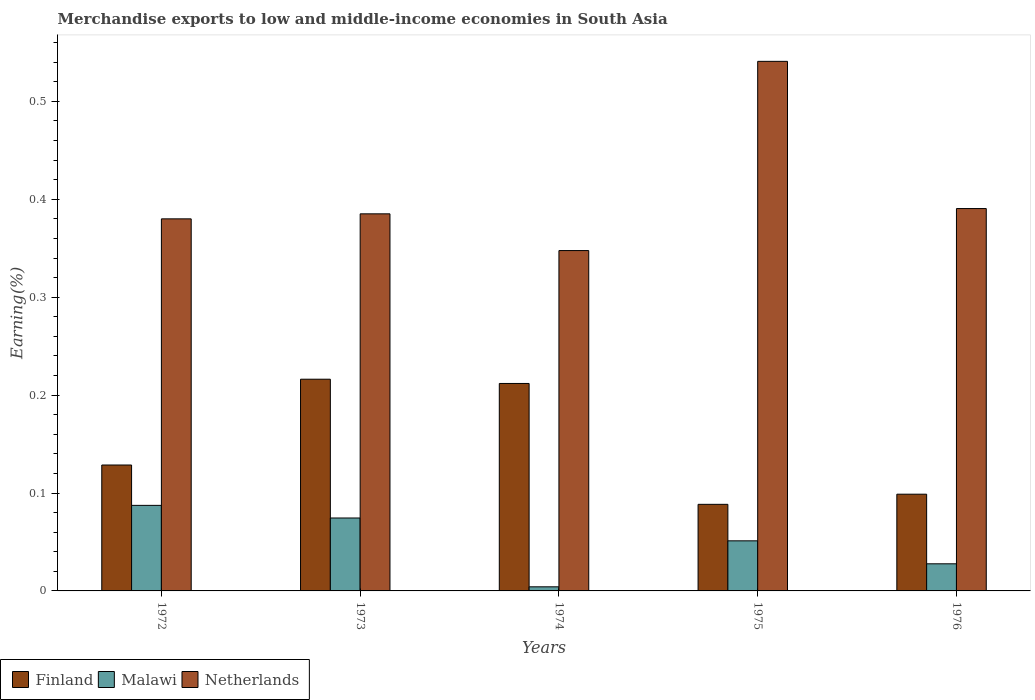How many different coloured bars are there?
Offer a very short reply. 3. How many groups of bars are there?
Offer a terse response. 5. Are the number of bars per tick equal to the number of legend labels?
Your answer should be compact. Yes. How many bars are there on the 5th tick from the left?
Provide a short and direct response. 3. How many bars are there on the 4th tick from the right?
Ensure brevity in your answer.  3. What is the label of the 5th group of bars from the left?
Your answer should be compact. 1976. What is the percentage of amount earned from merchandise exports in Malawi in 1976?
Make the answer very short. 0.03. Across all years, what is the maximum percentage of amount earned from merchandise exports in Malawi?
Provide a succinct answer. 0.09. Across all years, what is the minimum percentage of amount earned from merchandise exports in Malawi?
Offer a terse response. 0. In which year was the percentage of amount earned from merchandise exports in Netherlands maximum?
Give a very brief answer. 1975. In which year was the percentage of amount earned from merchandise exports in Finland minimum?
Give a very brief answer. 1975. What is the total percentage of amount earned from merchandise exports in Netherlands in the graph?
Keep it short and to the point. 2.04. What is the difference between the percentage of amount earned from merchandise exports in Netherlands in 1973 and that in 1975?
Your response must be concise. -0.16. What is the difference between the percentage of amount earned from merchandise exports in Netherlands in 1973 and the percentage of amount earned from merchandise exports in Finland in 1976?
Offer a terse response. 0.29. What is the average percentage of amount earned from merchandise exports in Malawi per year?
Provide a succinct answer. 0.05. In the year 1976, what is the difference between the percentage of amount earned from merchandise exports in Finland and percentage of amount earned from merchandise exports in Netherlands?
Provide a succinct answer. -0.29. What is the ratio of the percentage of amount earned from merchandise exports in Finland in 1972 to that in 1974?
Ensure brevity in your answer.  0.61. Is the percentage of amount earned from merchandise exports in Malawi in 1974 less than that in 1975?
Offer a terse response. Yes. Is the difference between the percentage of amount earned from merchandise exports in Finland in 1973 and 1976 greater than the difference between the percentage of amount earned from merchandise exports in Netherlands in 1973 and 1976?
Ensure brevity in your answer.  Yes. What is the difference between the highest and the second highest percentage of amount earned from merchandise exports in Finland?
Provide a succinct answer. 0. What is the difference between the highest and the lowest percentage of amount earned from merchandise exports in Netherlands?
Offer a terse response. 0.19. In how many years, is the percentage of amount earned from merchandise exports in Netherlands greater than the average percentage of amount earned from merchandise exports in Netherlands taken over all years?
Give a very brief answer. 1. What does the 2nd bar from the left in 1976 represents?
Your answer should be compact. Malawi. What does the 2nd bar from the right in 1974 represents?
Your answer should be compact. Malawi. Is it the case that in every year, the sum of the percentage of amount earned from merchandise exports in Finland and percentage of amount earned from merchandise exports in Netherlands is greater than the percentage of amount earned from merchandise exports in Malawi?
Your response must be concise. Yes. Are all the bars in the graph horizontal?
Your answer should be very brief. No. How many years are there in the graph?
Keep it short and to the point. 5. Are the values on the major ticks of Y-axis written in scientific E-notation?
Your answer should be compact. No. Does the graph contain any zero values?
Offer a terse response. No. How many legend labels are there?
Make the answer very short. 3. What is the title of the graph?
Ensure brevity in your answer.  Merchandise exports to low and middle-income economies in South Asia. What is the label or title of the Y-axis?
Your response must be concise. Earning(%). What is the Earning(%) of Finland in 1972?
Your response must be concise. 0.13. What is the Earning(%) in Malawi in 1972?
Keep it short and to the point. 0.09. What is the Earning(%) in Netherlands in 1972?
Give a very brief answer. 0.38. What is the Earning(%) in Finland in 1973?
Ensure brevity in your answer.  0.22. What is the Earning(%) of Malawi in 1973?
Your answer should be very brief. 0.07. What is the Earning(%) of Netherlands in 1973?
Give a very brief answer. 0.39. What is the Earning(%) of Finland in 1974?
Provide a succinct answer. 0.21. What is the Earning(%) in Malawi in 1974?
Your response must be concise. 0. What is the Earning(%) in Netherlands in 1974?
Your answer should be very brief. 0.35. What is the Earning(%) in Finland in 1975?
Provide a succinct answer. 0.09. What is the Earning(%) of Malawi in 1975?
Ensure brevity in your answer.  0.05. What is the Earning(%) of Netherlands in 1975?
Your response must be concise. 0.54. What is the Earning(%) of Finland in 1976?
Give a very brief answer. 0.1. What is the Earning(%) in Malawi in 1976?
Your answer should be compact. 0.03. What is the Earning(%) in Netherlands in 1976?
Your response must be concise. 0.39. Across all years, what is the maximum Earning(%) in Finland?
Ensure brevity in your answer.  0.22. Across all years, what is the maximum Earning(%) of Malawi?
Your answer should be very brief. 0.09. Across all years, what is the maximum Earning(%) in Netherlands?
Give a very brief answer. 0.54. Across all years, what is the minimum Earning(%) of Finland?
Give a very brief answer. 0.09. Across all years, what is the minimum Earning(%) in Malawi?
Your answer should be compact. 0. Across all years, what is the minimum Earning(%) of Netherlands?
Offer a terse response. 0.35. What is the total Earning(%) in Finland in the graph?
Ensure brevity in your answer.  0.74. What is the total Earning(%) in Malawi in the graph?
Your response must be concise. 0.24. What is the total Earning(%) in Netherlands in the graph?
Your answer should be compact. 2.04. What is the difference between the Earning(%) in Finland in 1972 and that in 1973?
Your answer should be very brief. -0.09. What is the difference between the Earning(%) in Malawi in 1972 and that in 1973?
Offer a very short reply. 0.01. What is the difference between the Earning(%) in Netherlands in 1972 and that in 1973?
Give a very brief answer. -0.01. What is the difference between the Earning(%) in Finland in 1972 and that in 1974?
Give a very brief answer. -0.08. What is the difference between the Earning(%) in Malawi in 1972 and that in 1974?
Offer a very short reply. 0.08. What is the difference between the Earning(%) in Netherlands in 1972 and that in 1974?
Provide a short and direct response. 0.03. What is the difference between the Earning(%) in Finland in 1972 and that in 1975?
Your response must be concise. 0.04. What is the difference between the Earning(%) in Malawi in 1972 and that in 1975?
Your answer should be very brief. 0.04. What is the difference between the Earning(%) in Netherlands in 1972 and that in 1975?
Provide a succinct answer. -0.16. What is the difference between the Earning(%) in Finland in 1972 and that in 1976?
Your answer should be very brief. 0.03. What is the difference between the Earning(%) in Malawi in 1972 and that in 1976?
Provide a short and direct response. 0.06. What is the difference between the Earning(%) of Netherlands in 1972 and that in 1976?
Ensure brevity in your answer.  -0.01. What is the difference between the Earning(%) of Finland in 1973 and that in 1974?
Offer a very short reply. 0. What is the difference between the Earning(%) of Malawi in 1973 and that in 1974?
Your answer should be very brief. 0.07. What is the difference between the Earning(%) in Netherlands in 1973 and that in 1974?
Offer a very short reply. 0.04. What is the difference between the Earning(%) in Finland in 1973 and that in 1975?
Make the answer very short. 0.13. What is the difference between the Earning(%) in Malawi in 1973 and that in 1975?
Ensure brevity in your answer.  0.02. What is the difference between the Earning(%) in Netherlands in 1973 and that in 1975?
Make the answer very short. -0.16. What is the difference between the Earning(%) in Finland in 1973 and that in 1976?
Ensure brevity in your answer.  0.12. What is the difference between the Earning(%) of Malawi in 1973 and that in 1976?
Ensure brevity in your answer.  0.05. What is the difference between the Earning(%) in Netherlands in 1973 and that in 1976?
Your response must be concise. -0.01. What is the difference between the Earning(%) in Finland in 1974 and that in 1975?
Your response must be concise. 0.12. What is the difference between the Earning(%) of Malawi in 1974 and that in 1975?
Provide a succinct answer. -0.05. What is the difference between the Earning(%) of Netherlands in 1974 and that in 1975?
Your answer should be very brief. -0.19. What is the difference between the Earning(%) in Finland in 1974 and that in 1976?
Your answer should be very brief. 0.11. What is the difference between the Earning(%) of Malawi in 1974 and that in 1976?
Keep it short and to the point. -0.02. What is the difference between the Earning(%) in Netherlands in 1974 and that in 1976?
Ensure brevity in your answer.  -0.04. What is the difference between the Earning(%) in Finland in 1975 and that in 1976?
Offer a very short reply. -0.01. What is the difference between the Earning(%) in Malawi in 1975 and that in 1976?
Provide a succinct answer. 0.02. What is the difference between the Earning(%) of Netherlands in 1975 and that in 1976?
Provide a short and direct response. 0.15. What is the difference between the Earning(%) of Finland in 1972 and the Earning(%) of Malawi in 1973?
Make the answer very short. 0.05. What is the difference between the Earning(%) of Finland in 1972 and the Earning(%) of Netherlands in 1973?
Provide a succinct answer. -0.26. What is the difference between the Earning(%) in Malawi in 1972 and the Earning(%) in Netherlands in 1973?
Keep it short and to the point. -0.3. What is the difference between the Earning(%) of Finland in 1972 and the Earning(%) of Malawi in 1974?
Your answer should be very brief. 0.12. What is the difference between the Earning(%) in Finland in 1972 and the Earning(%) in Netherlands in 1974?
Your answer should be very brief. -0.22. What is the difference between the Earning(%) of Malawi in 1972 and the Earning(%) of Netherlands in 1974?
Provide a short and direct response. -0.26. What is the difference between the Earning(%) in Finland in 1972 and the Earning(%) in Malawi in 1975?
Ensure brevity in your answer.  0.08. What is the difference between the Earning(%) in Finland in 1972 and the Earning(%) in Netherlands in 1975?
Offer a terse response. -0.41. What is the difference between the Earning(%) in Malawi in 1972 and the Earning(%) in Netherlands in 1975?
Ensure brevity in your answer.  -0.45. What is the difference between the Earning(%) of Finland in 1972 and the Earning(%) of Malawi in 1976?
Your answer should be very brief. 0.1. What is the difference between the Earning(%) in Finland in 1972 and the Earning(%) in Netherlands in 1976?
Your response must be concise. -0.26. What is the difference between the Earning(%) in Malawi in 1972 and the Earning(%) in Netherlands in 1976?
Make the answer very short. -0.3. What is the difference between the Earning(%) in Finland in 1973 and the Earning(%) in Malawi in 1974?
Make the answer very short. 0.21. What is the difference between the Earning(%) in Finland in 1973 and the Earning(%) in Netherlands in 1974?
Keep it short and to the point. -0.13. What is the difference between the Earning(%) in Malawi in 1973 and the Earning(%) in Netherlands in 1974?
Offer a terse response. -0.27. What is the difference between the Earning(%) of Finland in 1973 and the Earning(%) of Malawi in 1975?
Offer a terse response. 0.17. What is the difference between the Earning(%) of Finland in 1973 and the Earning(%) of Netherlands in 1975?
Make the answer very short. -0.32. What is the difference between the Earning(%) of Malawi in 1973 and the Earning(%) of Netherlands in 1975?
Offer a very short reply. -0.47. What is the difference between the Earning(%) in Finland in 1973 and the Earning(%) in Malawi in 1976?
Your answer should be compact. 0.19. What is the difference between the Earning(%) of Finland in 1973 and the Earning(%) of Netherlands in 1976?
Offer a very short reply. -0.17. What is the difference between the Earning(%) of Malawi in 1973 and the Earning(%) of Netherlands in 1976?
Offer a very short reply. -0.32. What is the difference between the Earning(%) in Finland in 1974 and the Earning(%) in Malawi in 1975?
Your answer should be compact. 0.16. What is the difference between the Earning(%) of Finland in 1974 and the Earning(%) of Netherlands in 1975?
Make the answer very short. -0.33. What is the difference between the Earning(%) in Malawi in 1974 and the Earning(%) in Netherlands in 1975?
Offer a terse response. -0.54. What is the difference between the Earning(%) of Finland in 1974 and the Earning(%) of Malawi in 1976?
Give a very brief answer. 0.18. What is the difference between the Earning(%) in Finland in 1974 and the Earning(%) in Netherlands in 1976?
Keep it short and to the point. -0.18. What is the difference between the Earning(%) of Malawi in 1974 and the Earning(%) of Netherlands in 1976?
Keep it short and to the point. -0.39. What is the difference between the Earning(%) in Finland in 1975 and the Earning(%) in Malawi in 1976?
Offer a terse response. 0.06. What is the difference between the Earning(%) in Finland in 1975 and the Earning(%) in Netherlands in 1976?
Your response must be concise. -0.3. What is the difference between the Earning(%) of Malawi in 1975 and the Earning(%) of Netherlands in 1976?
Your response must be concise. -0.34. What is the average Earning(%) of Finland per year?
Give a very brief answer. 0.15. What is the average Earning(%) in Malawi per year?
Give a very brief answer. 0.05. What is the average Earning(%) in Netherlands per year?
Offer a terse response. 0.41. In the year 1972, what is the difference between the Earning(%) of Finland and Earning(%) of Malawi?
Offer a very short reply. 0.04. In the year 1972, what is the difference between the Earning(%) of Finland and Earning(%) of Netherlands?
Ensure brevity in your answer.  -0.25. In the year 1972, what is the difference between the Earning(%) in Malawi and Earning(%) in Netherlands?
Provide a short and direct response. -0.29. In the year 1973, what is the difference between the Earning(%) in Finland and Earning(%) in Malawi?
Your answer should be very brief. 0.14. In the year 1973, what is the difference between the Earning(%) of Finland and Earning(%) of Netherlands?
Provide a short and direct response. -0.17. In the year 1973, what is the difference between the Earning(%) of Malawi and Earning(%) of Netherlands?
Offer a very short reply. -0.31. In the year 1974, what is the difference between the Earning(%) in Finland and Earning(%) in Malawi?
Your answer should be very brief. 0.21. In the year 1974, what is the difference between the Earning(%) in Finland and Earning(%) in Netherlands?
Your response must be concise. -0.14. In the year 1974, what is the difference between the Earning(%) in Malawi and Earning(%) in Netherlands?
Your response must be concise. -0.34. In the year 1975, what is the difference between the Earning(%) of Finland and Earning(%) of Malawi?
Offer a very short reply. 0.04. In the year 1975, what is the difference between the Earning(%) of Finland and Earning(%) of Netherlands?
Provide a short and direct response. -0.45. In the year 1975, what is the difference between the Earning(%) in Malawi and Earning(%) in Netherlands?
Ensure brevity in your answer.  -0.49. In the year 1976, what is the difference between the Earning(%) in Finland and Earning(%) in Malawi?
Your answer should be very brief. 0.07. In the year 1976, what is the difference between the Earning(%) of Finland and Earning(%) of Netherlands?
Your answer should be compact. -0.29. In the year 1976, what is the difference between the Earning(%) in Malawi and Earning(%) in Netherlands?
Offer a terse response. -0.36. What is the ratio of the Earning(%) in Finland in 1972 to that in 1973?
Your answer should be compact. 0.59. What is the ratio of the Earning(%) in Malawi in 1972 to that in 1973?
Ensure brevity in your answer.  1.17. What is the ratio of the Earning(%) in Netherlands in 1972 to that in 1973?
Give a very brief answer. 0.99. What is the ratio of the Earning(%) of Finland in 1972 to that in 1974?
Give a very brief answer. 0.61. What is the ratio of the Earning(%) in Malawi in 1972 to that in 1974?
Your answer should be very brief. 20.83. What is the ratio of the Earning(%) in Netherlands in 1972 to that in 1974?
Ensure brevity in your answer.  1.09. What is the ratio of the Earning(%) in Finland in 1972 to that in 1975?
Your response must be concise. 1.45. What is the ratio of the Earning(%) in Malawi in 1972 to that in 1975?
Your response must be concise. 1.71. What is the ratio of the Earning(%) of Netherlands in 1972 to that in 1975?
Your answer should be very brief. 0.7. What is the ratio of the Earning(%) in Finland in 1972 to that in 1976?
Your answer should be compact. 1.3. What is the ratio of the Earning(%) of Malawi in 1972 to that in 1976?
Keep it short and to the point. 3.16. What is the ratio of the Earning(%) in Netherlands in 1972 to that in 1976?
Ensure brevity in your answer.  0.97. What is the ratio of the Earning(%) of Finland in 1973 to that in 1974?
Provide a succinct answer. 1.02. What is the ratio of the Earning(%) in Malawi in 1973 to that in 1974?
Your response must be concise. 17.76. What is the ratio of the Earning(%) of Netherlands in 1973 to that in 1974?
Provide a short and direct response. 1.11. What is the ratio of the Earning(%) in Finland in 1973 to that in 1975?
Ensure brevity in your answer.  2.45. What is the ratio of the Earning(%) in Malawi in 1973 to that in 1975?
Offer a terse response. 1.46. What is the ratio of the Earning(%) of Netherlands in 1973 to that in 1975?
Offer a very short reply. 0.71. What is the ratio of the Earning(%) in Finland in 1973 to that in 1976?
Offer a very short reply. 2.19. What is the ratio of the Earning(%) in Malawi in 1973 to that in 1976?
Your answer should be compact. 2.69. What is the ratio of the Earning(%) of Netherlands in 1973 to that in 1976?
Offer a terse response. 0.99. What is the ratio of the Earning(%) of Finland in 1974 to that in 1975?
Provide a succinct answer. 2.4. What is the ratio of the Earning(%) in Malawi in 1974 to that in 1975?
Offer a very short reply. 0.08. What is the ratio of the Earning(%) in Netherlands in 1974 to that in 1975?
Offer a terse response. 0.64. What is the ratio of the Earning(%) of Finland in 1974 to that in 1976?
Your answer should be very brief. 2.14. What is the ratio of the Earning(%) in Malawi in 1974 to that in 1976?
Make the answer very short. 0.15. What is the ratio of the Earning(%) in Netherlands in 1974 to that in 1976?
Make the answer very short. 0.89. What is the ratio of the Earning(%) in Finland in 1975 to that in 1976?
Make the answer very short. 0.9. What is the ratio of the Earning(%) in Malawi in 1975 to that in 1976?
Ensure brevity in your answer.  1.85. What is the ratio of the Earning(%) of Netherlands in 1975 to that in 1976?
Offer a very short reply. 1.38. What is the difference between the highest and the second highest Earning(%) of Finland?
Your answer should be compact. 0. What is the difference between the highest and the second highest Earning(%) in Malawi?
Keep it short and to the point. 0.01. What is the difference between the highest and the second highest Earning(%) in Netherlands?
Give a very brief answer. 0.15. What is the difference between the highest and the lowest Earning(%) in Finland?
Offer a very short reply. 0.13. What is the difference between the highest and the lowest Earning(%) of Malawi?
Your answer should be compact. 0.08. What is the difference between the highest and the lowest Earning(%) of Netherlands?
Offer a terse response. 0.19. 